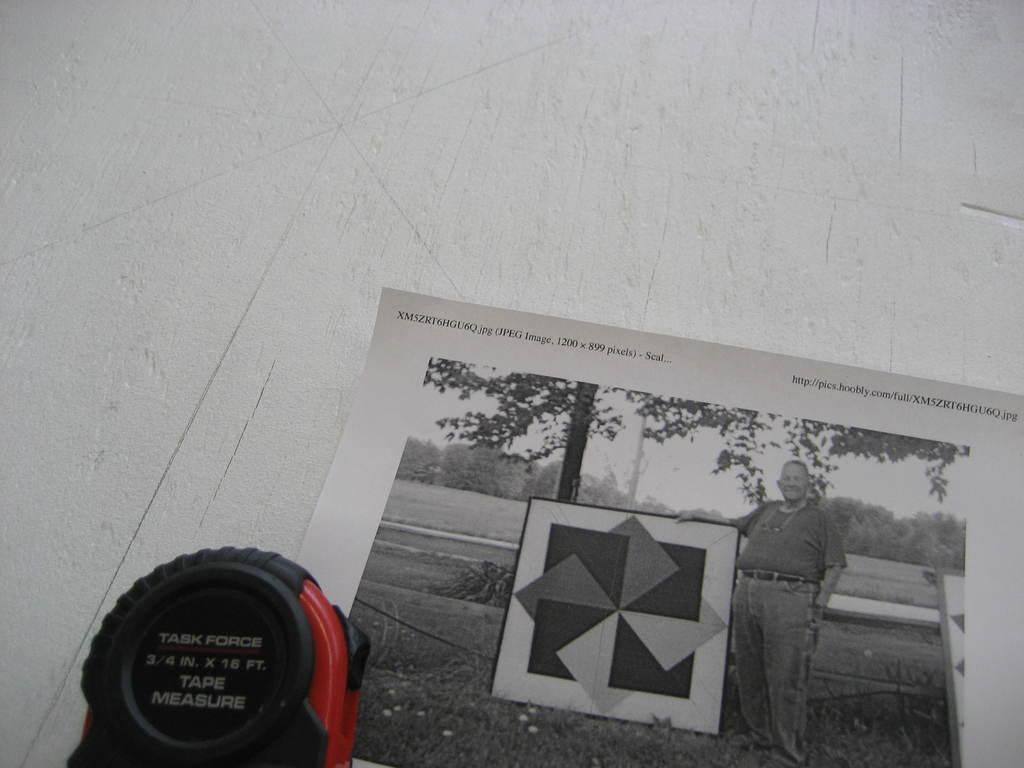Could you give a brief overview of what you see in this image? In this image we can see a poster with some text and a picture and in the picture we can see a person holding a board and there are some trees and grass on the ground. We can see an object and there is some text on it and these are placed on a white surface which looks like a table. 